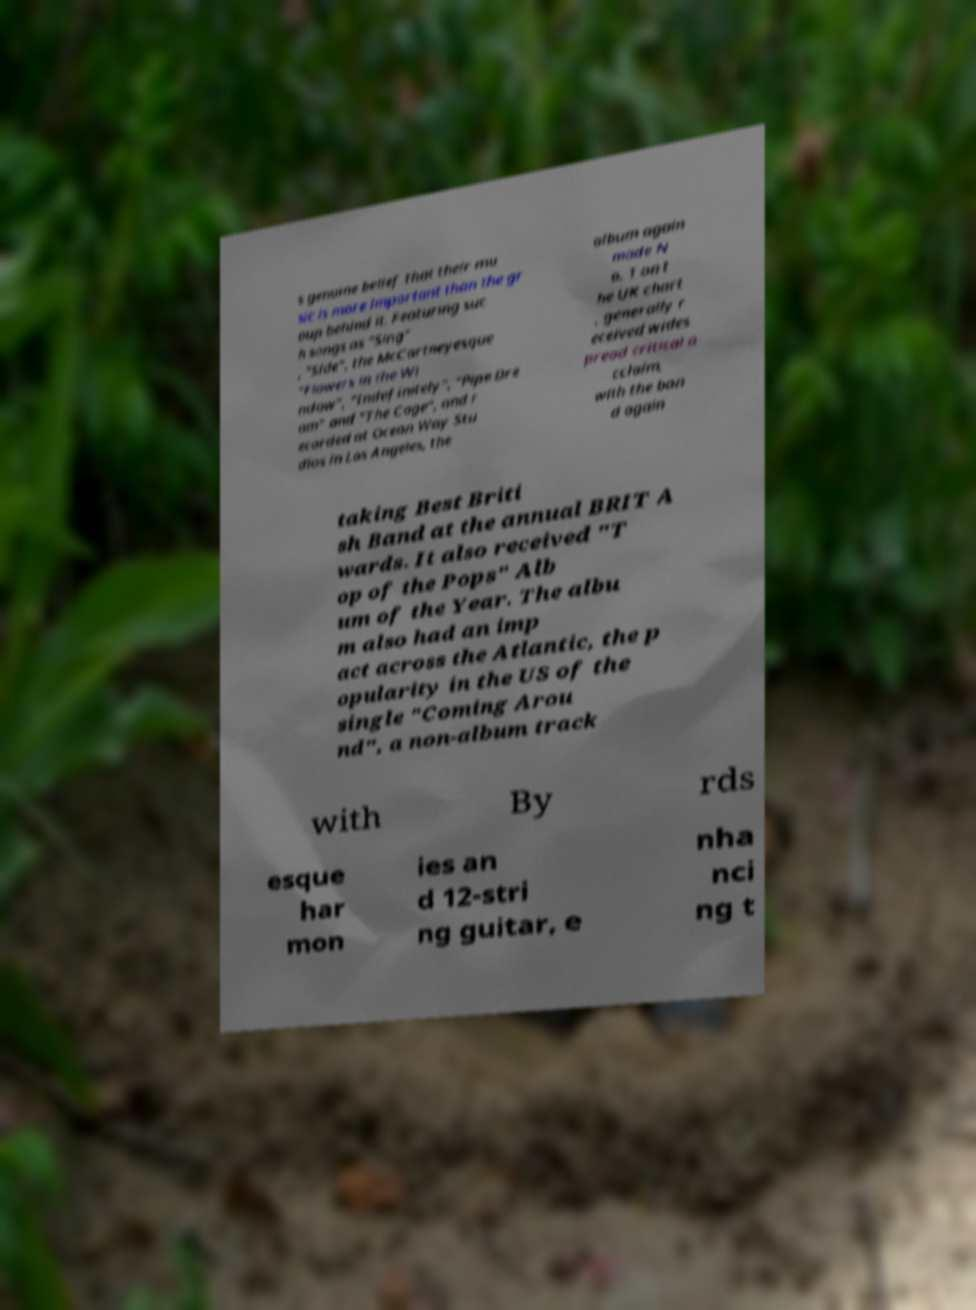I need the written content from this picture converted into text. Can you do that? s genuine belief that their mu sic is more important than the gr oup behind it. Featuring suc h songs as "Sing" , "Side", the McCartneyesque "Flowers in the Wi ndow", "Indefinitely", "Pipe Dre am" and "The Cage", and r ecorded at Ocean Way Stu dios in Los Angeles, the album again made N o. 1 on t he UK chart , generally r eceived wides pread critical a cclaim, with the ban d again taking Best Briti sh Band at the annual BRIT A wards. It also received "T op of the Pops" Alb um of the Year. The albu m also had an imp act across the Atlantic, the p opularity in the US of the single "Coming Arou nd", a non-album track with By rds esque har mon ies an d 12-stri ng guitar, e nha nci ng t 